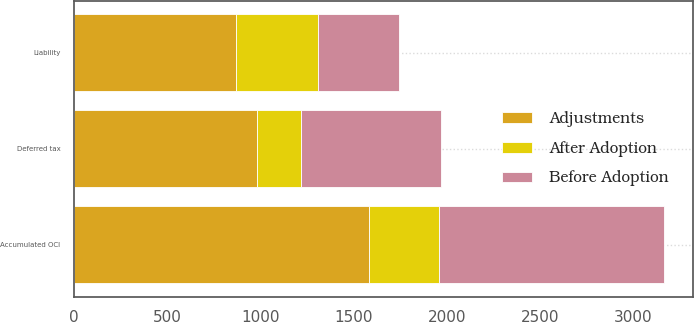Convert chart. <chart><loc_0><loc_0><loc_500><loc_500><stacked_bar_chart><ecel><fcel>Liability<fcel>Deferred tax<fcel>Accumulated OCI<nl><fcel>Before Adoption<fcel>435<fcel>749<fcel>1204<nl><fcel>After Adoption<fcel>436<fcel>235<fcel>377<nl><fcel>Adjustments<fcel>871<fcel>984<fcel>1581<nl></chart> 